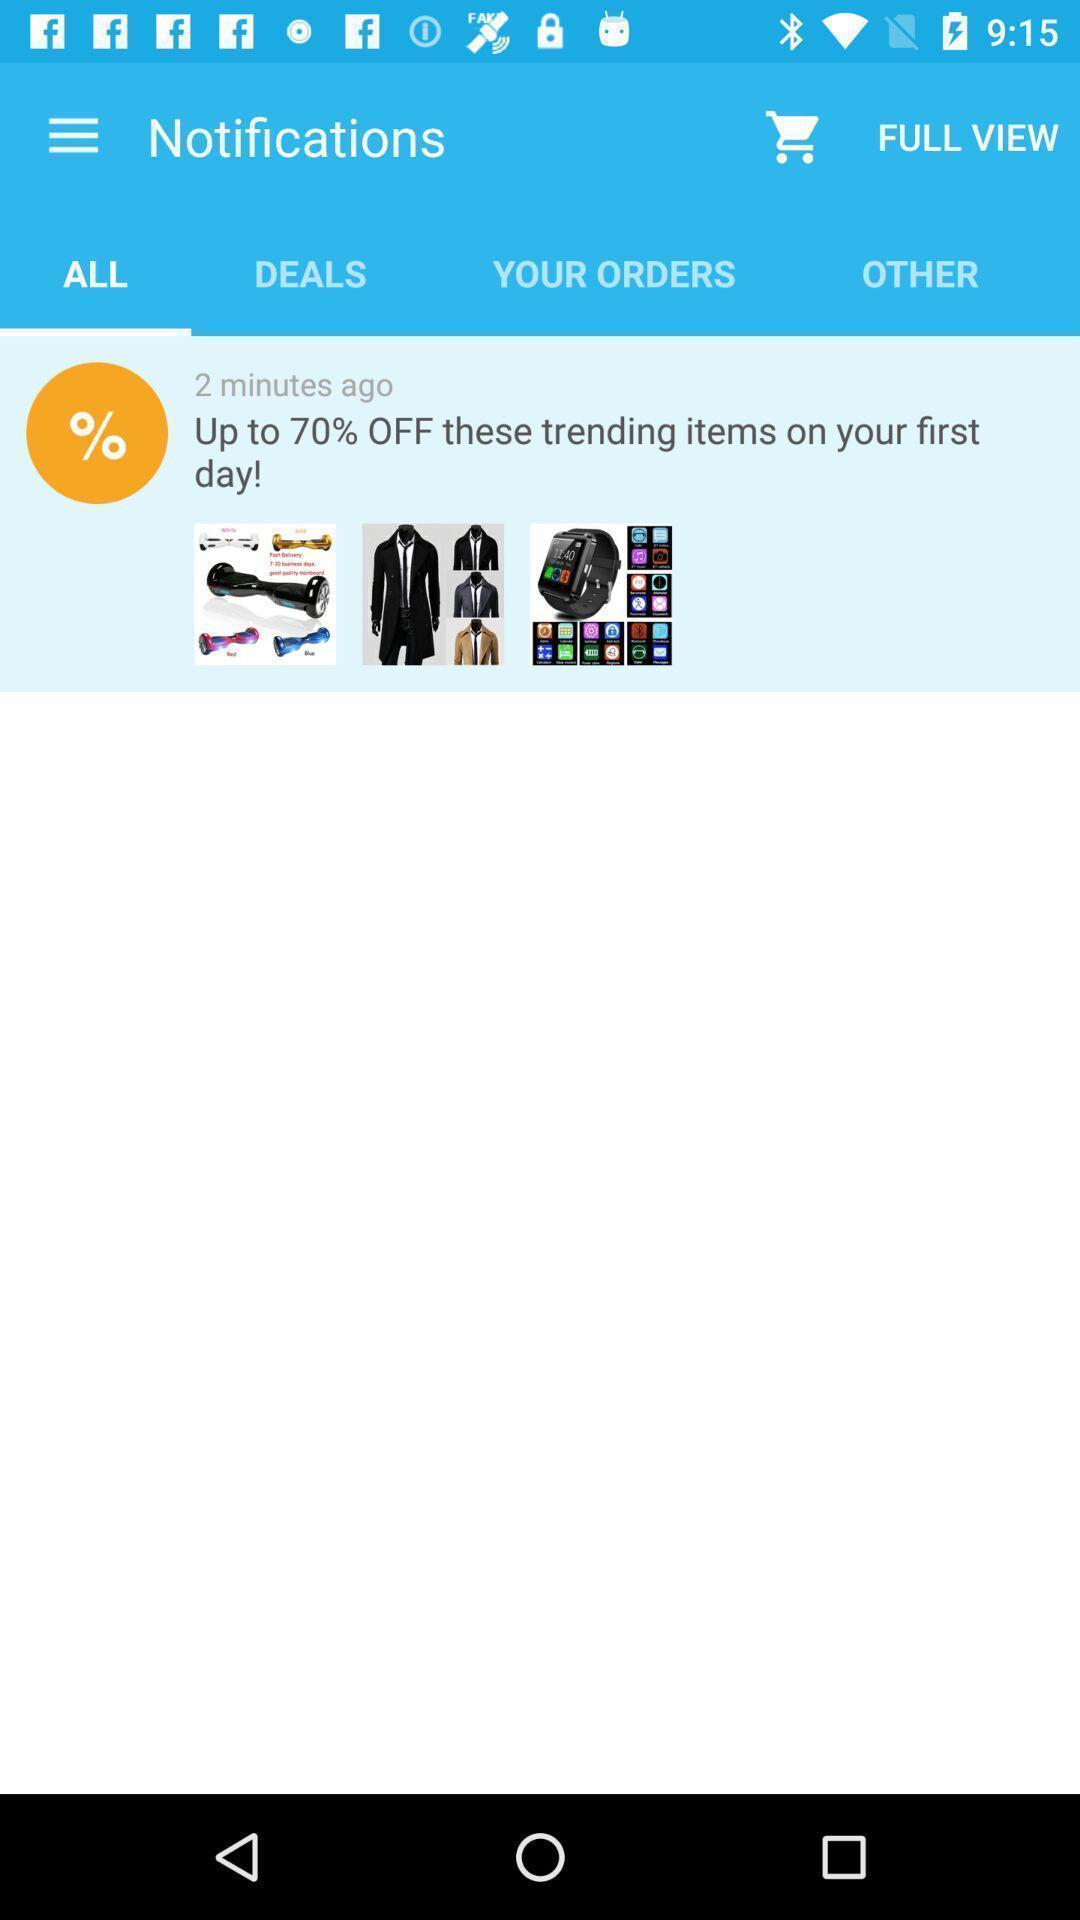What can you discern from this picture? Screen displaying contents in notifications page of a shopping application. 